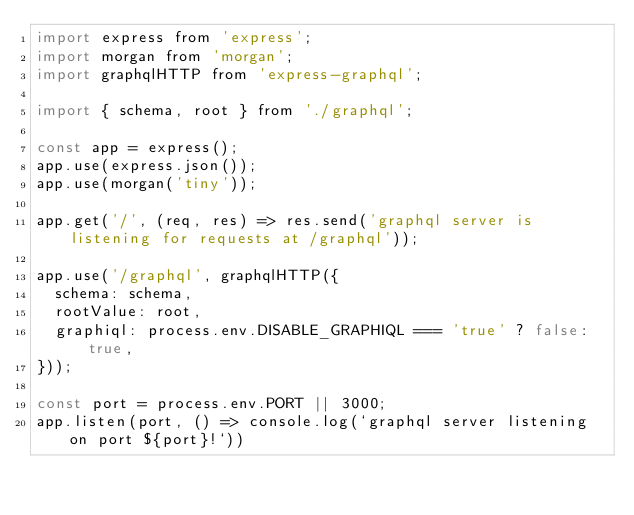<code> <loc_0><loc_0><loc_500><loc_500><_JavaScript_>import express from 'express';
import morgan from 'morgan';
import graphqlHTTP from 'express-graphql';

import { schema, root } from './graphql';

const app = express();
app.use(express.json()); 
app.use(morgan('tiny'));

app.get('/', (req, res) => res.send('graphql server is listening for requests at /graphql'));

app.use('/graphql', graphqlHTTP({
  schema: schema,
  rootValue: root,
  graphiql: process.env.DISABLE_GRAPHIQL === 'true' ? false: true,
}));

const port = process.env.PORT || 3000;
app.listen(port, () => console.log(`graphql server listening on port ${port}!`))</code> 